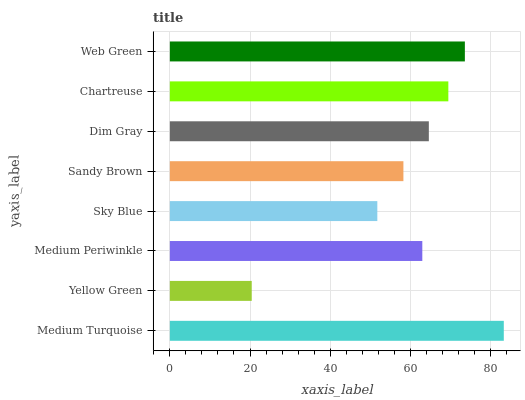Is Yellow Green the minimum?
Answer yes or no. Yes. Is Medium Turquoise the maximum?
Answer yes or no. Yes. Is Medium Periwinkle the minimum?
Answer yes or no. No. Is Medium Periwinkle the maximum?
Answer yes or no. No. Is Medium Periwinkle greater than Yellow Green?
Answer yes or no. Yes. Is Yellow Green less than Medium Periwinkle?
Answer yes or no. Yes. Is Yellow Green greater than Medium Periwinkle?
Answer yes or no. No. Is Medium Periwinkle less than Yellow Green?
Answer yes or no. No. Is Dim Gray the high median?
Answer yes or no. Yes. Is Medium Periwinkle the low median?
Answer yes or no. Yes. Is Sandy Brown the high median?
Answer yes or no. No. Is Medium Turquoise the low median?
Answer yes or no. No. 